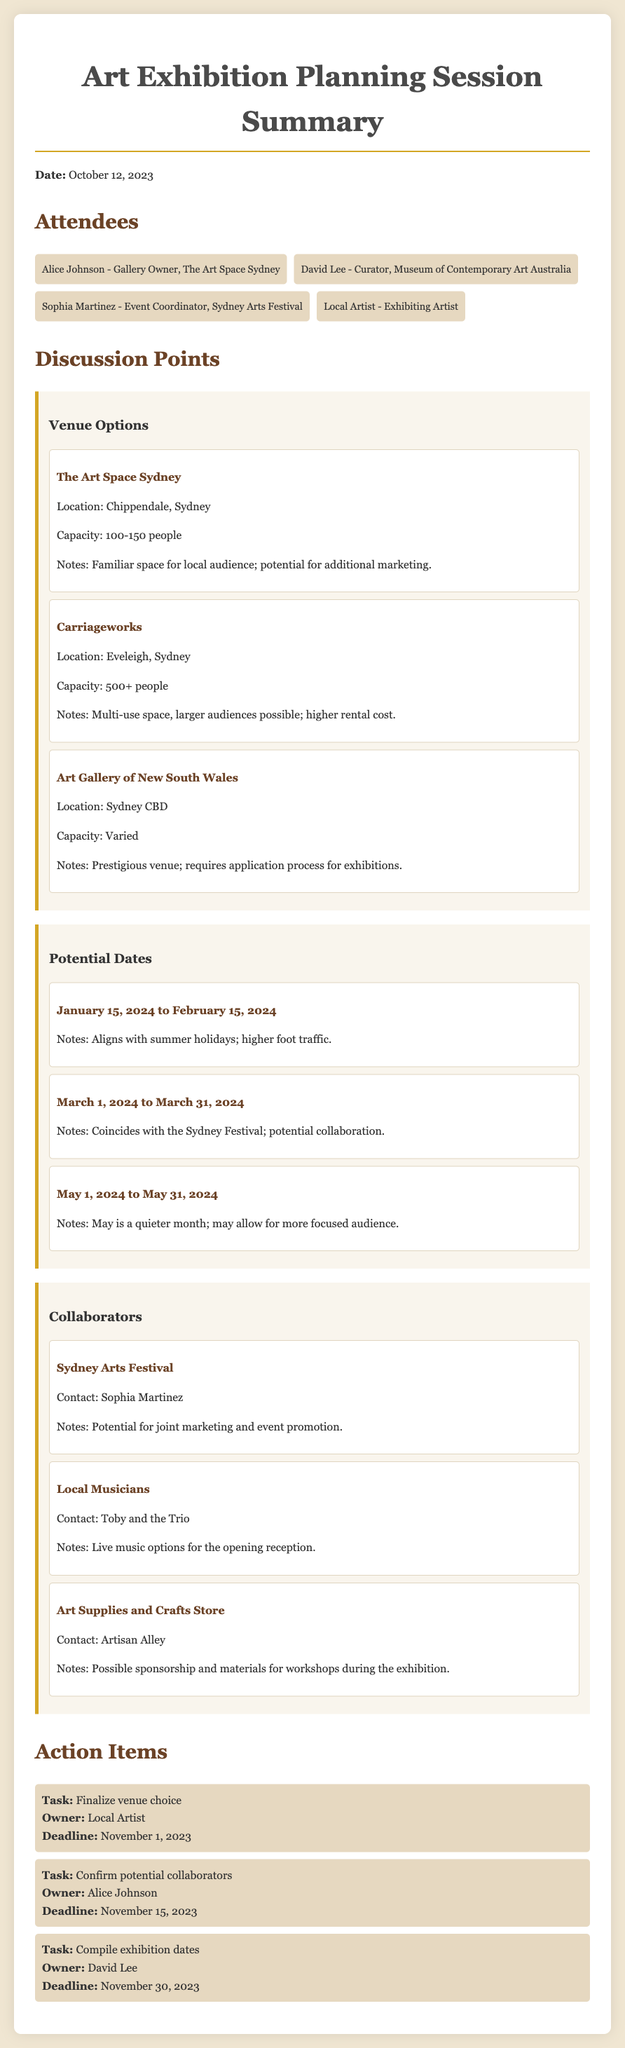what is the date of the meeting? The date of the meeting is explicitly stated at the beginning of the document.
Answer: October 12, 2023 who is the event coordinator mentioned? The document lists Sophia Martinez as the event coordinator among the attendees.
Answer: Sophia Martinez what is the capacity of Carriageworks? The document specifies the capacity of Carriageworks in the venue options section.
Answer: 500+ people what are the potential exhibition dates? The document discusses multiple date ranges for the exhibition; we can refer to any of them.
Answer: January 15, 2024 to February 15, 2024 who is the contact person for Sydney Arts Festival? The document indicates the contact person associated with Sydney Arts Festival in the collaborators section.
Answer: Sophia Martinez which venue requires an application process for exhibitions? The document mentions this specific detail about one of the venues.
Answer: Art Gallery of New South Wales what is one reason for choosing January as a potential date? The document notes a particular benefit related to higher foot traffic during that time.
Answer: Higher foot traffic who is responsible for confirming potential collaborators? The action items specify the owner responsible for this task in the action items section.
Answer: Alice Johnson 